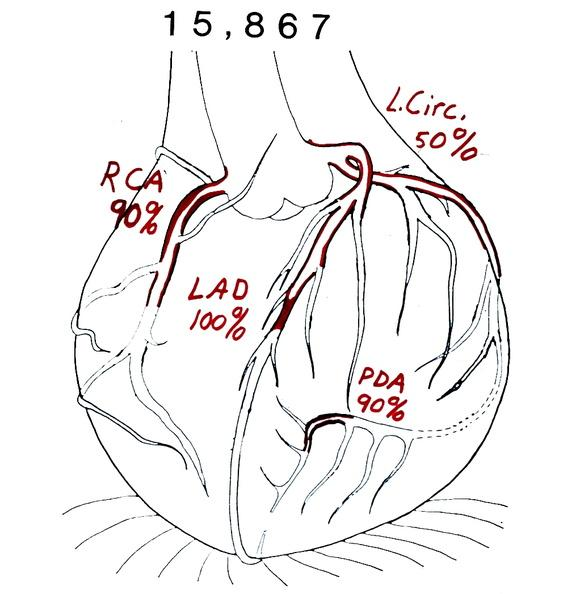s carcinomatosis present?
Answer the question using a single word or phrase. No 